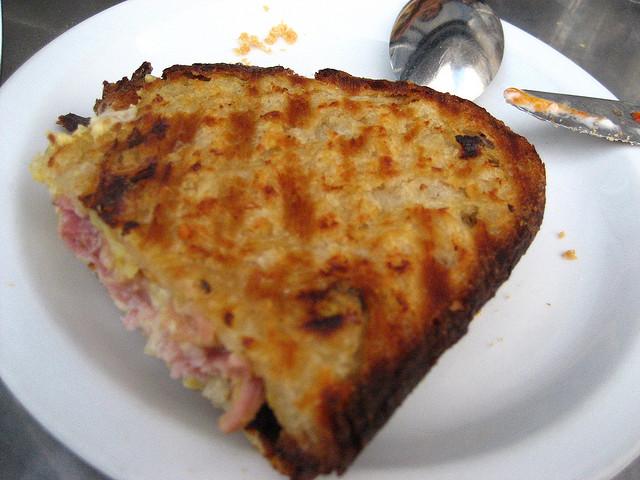Has the knife been used recently?
Quick response, please. Yes. What color is the plate?
Answer briefly. White. Is the food burnt?
Write a very short answer. No. Is this a sandwich?
Quick response, please. Yes. Is the pizza warm and gooey?
Quick response, please. Yes. 